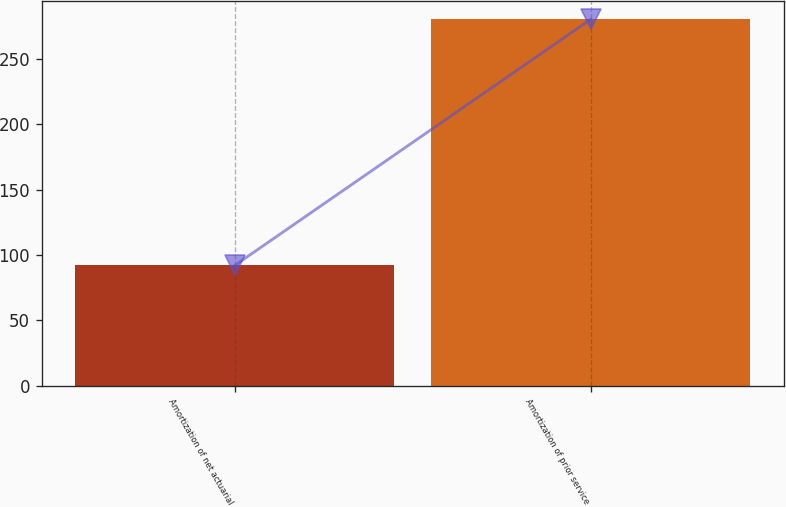Convert chart. <chart><loc_0><loc_0><loc_500><loc_500><bar_chart><fcel>Amortization of net actuarial<fcel>Amortization of prior service<nl><fcel>92<fcel>280<nl></chart> 